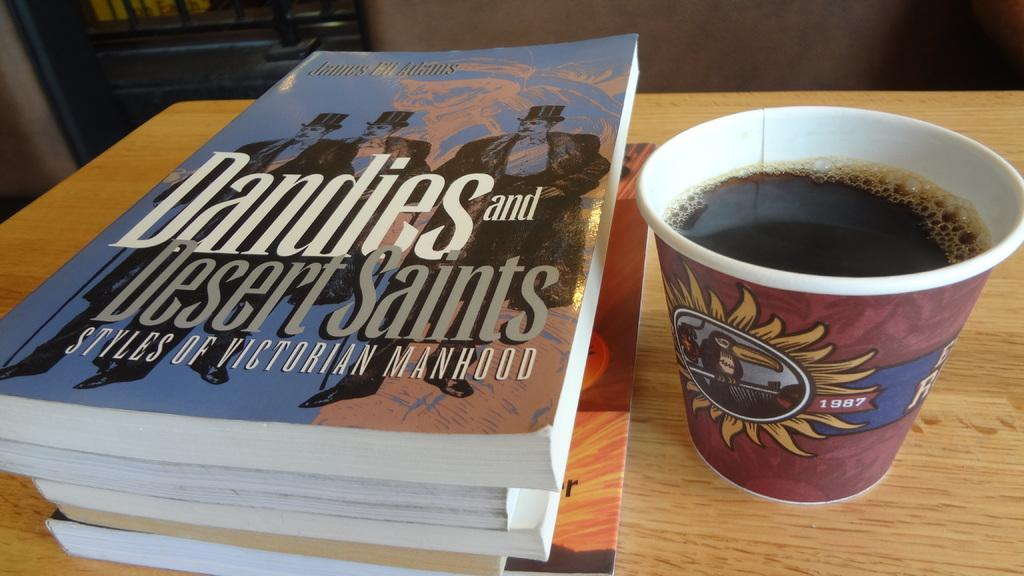<image>
Relay a brief, clear account of the picture shown. The book Dandies and Desert Saints is on top of a stack of books. 